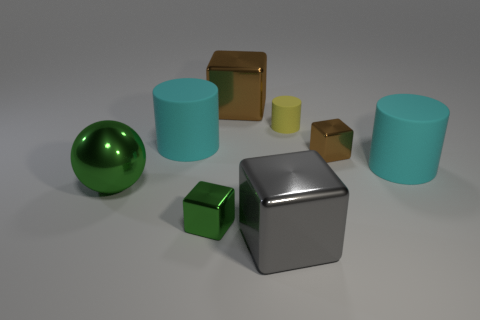Add 1 brown objects. How many objects exist? 9 Subtract all cylinders. How many objects are left? 5 Subtract all large rubber objects. Subtract all metal cubes. How many objects are left? 2 Add 8 small metallic things. How many small metallic things are left? 10 Add 4 big matte objects. How many big matte objects exist? 6 Subtract 1 gray blocks. How many objects are left? 7 